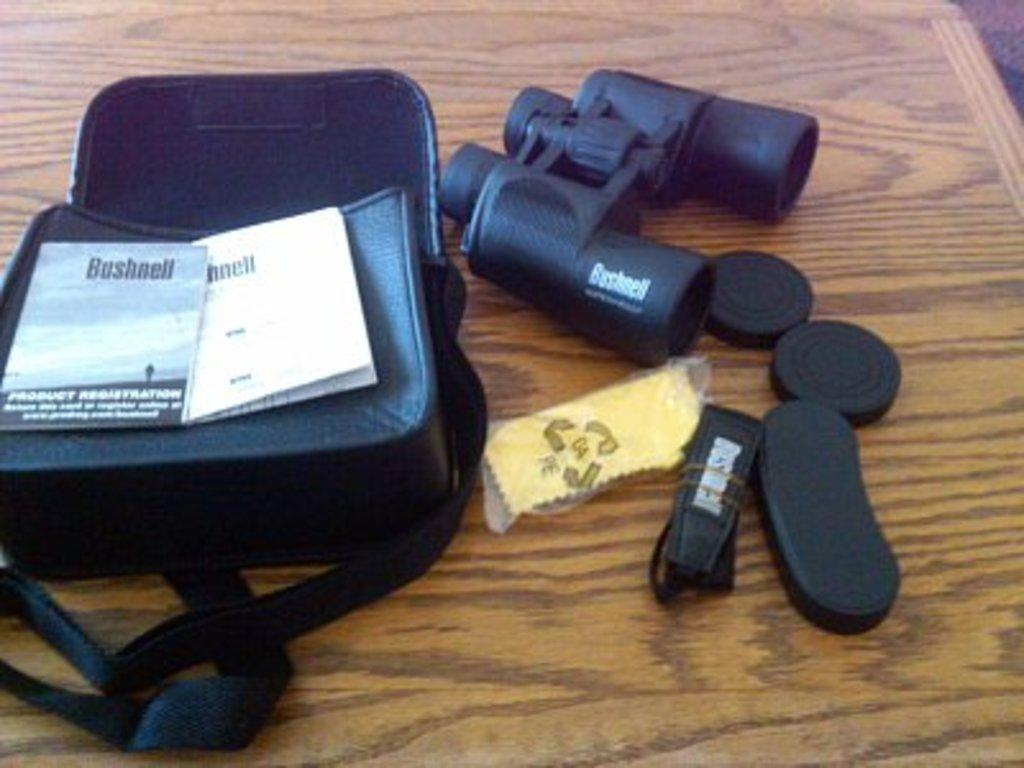What object is present in the image that is typically used for carrying items? There is a bag in the image that is typically used for carrying items. What type of items can be seen in the image? Papers are visible in the image. What device is present in the image that is used for magnifying distant objects? There are binoculars in the image that are used for magnifying distant objects. What is the surface on which the items are placed in the image? The items are placed on a wooden plank in the image. What activity is the flame performing in the image? There is no flame present in the image, so no activity can be observed. 